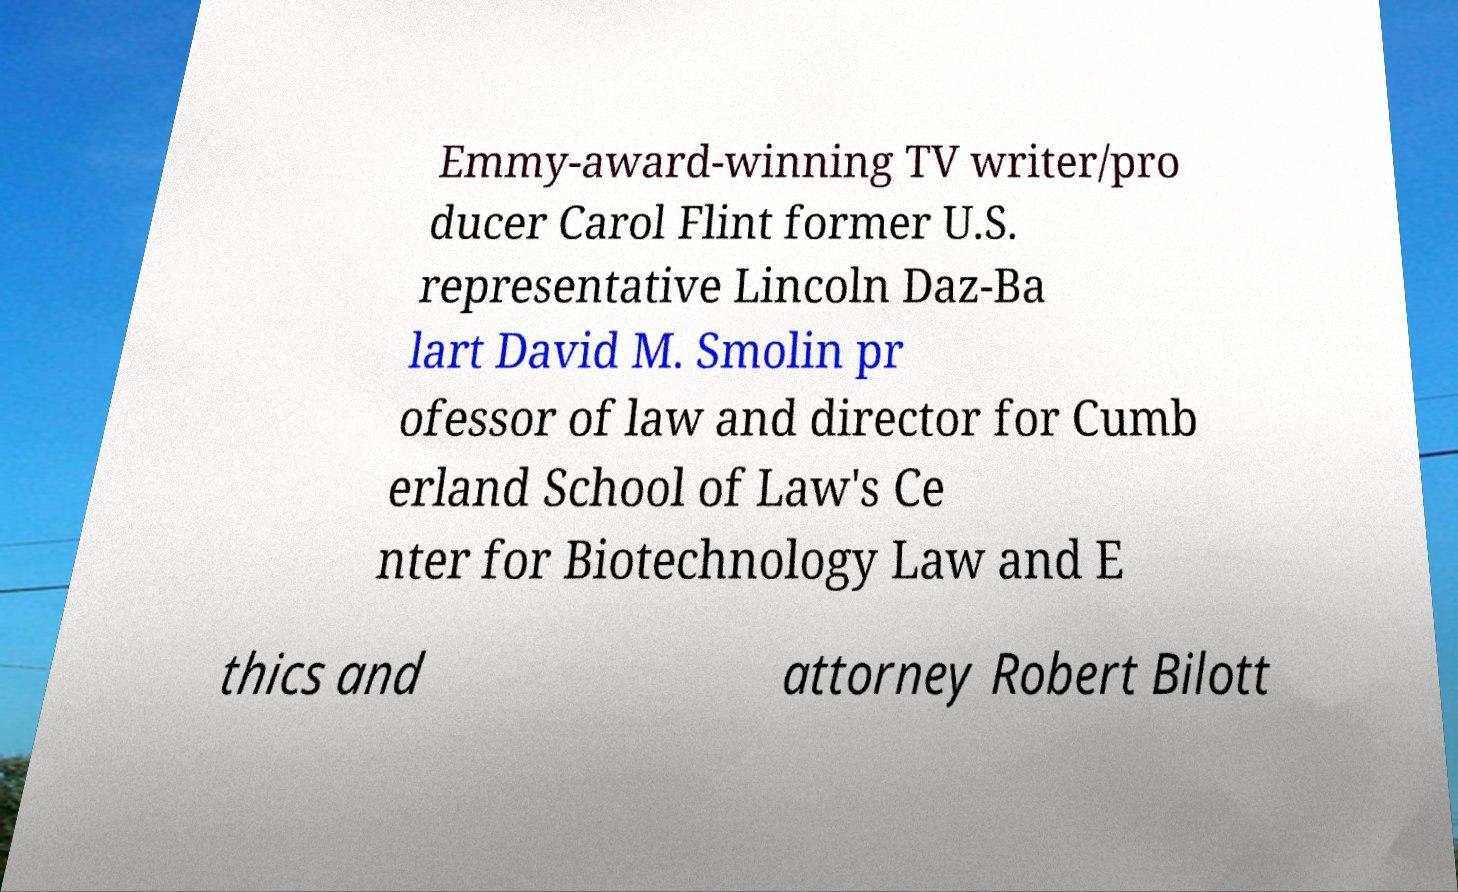For documentation purposes, I need the text within this image transcribed. Could you provide that? Emmy-award-winning TV writer/pro ducer Carol Flint former U.S. representative Lincoln Daz-Ba lart David M. Smolin pr ofessor of law and director for Cumb erland School of Law's Ce nter for Biotechnology Law and E thics and attorney Robert Bilott 